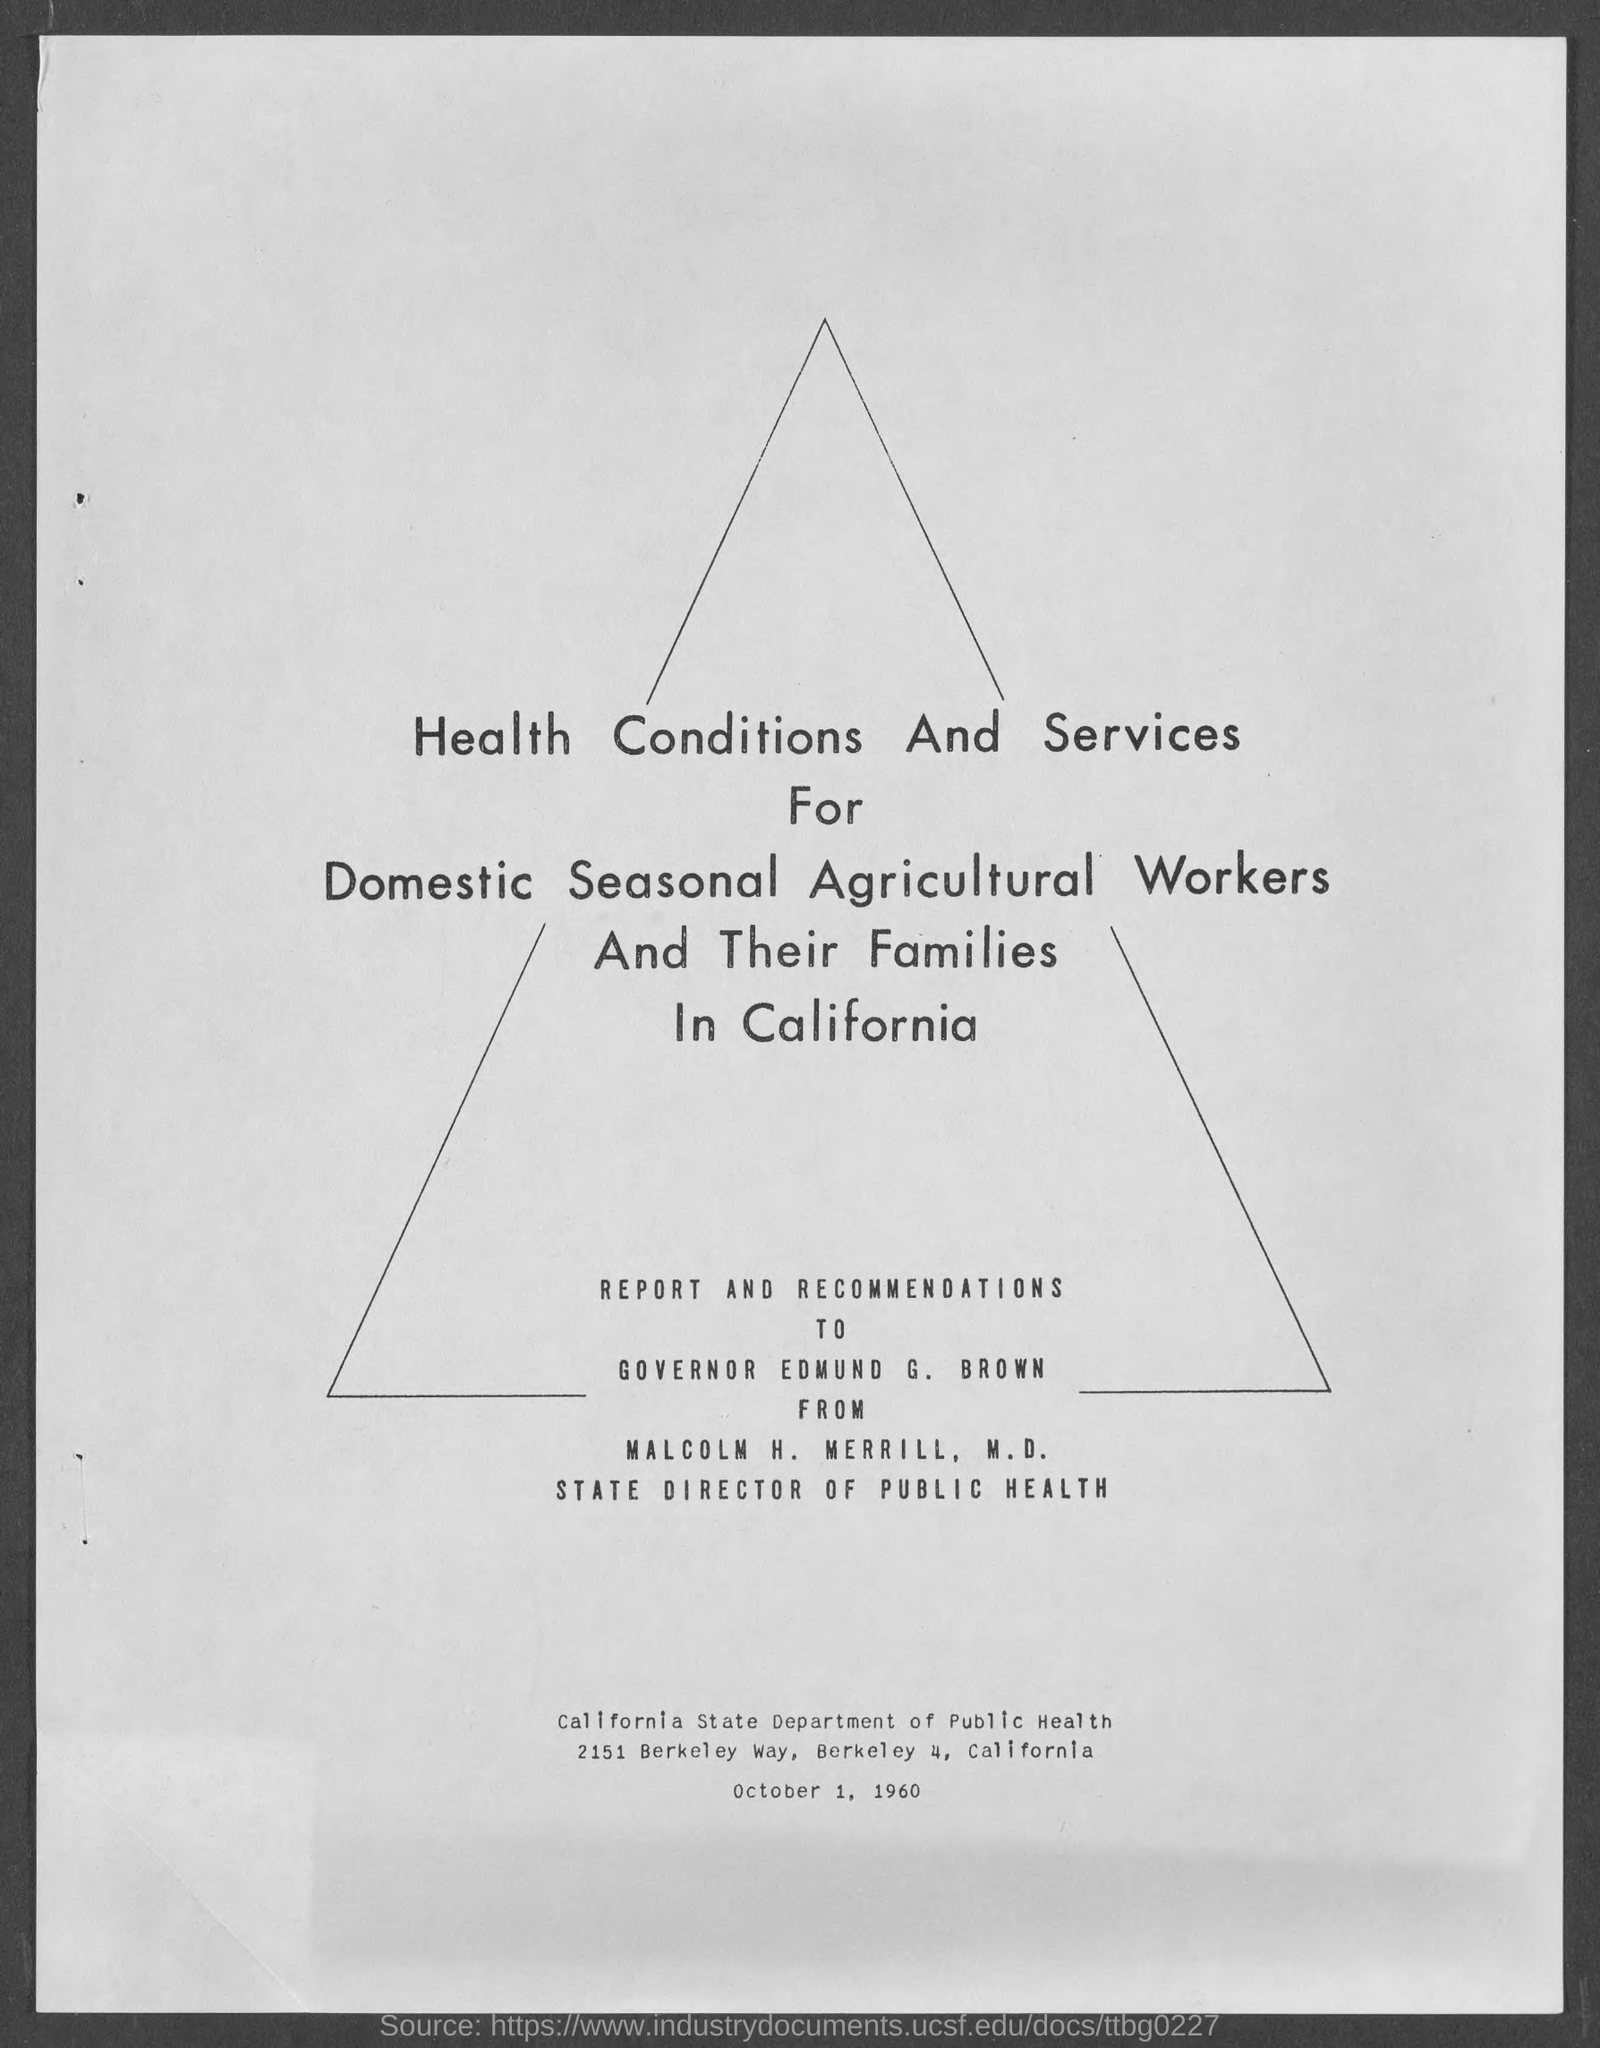Who is the state director of public health ?
Your answer should be compact. Malcolm H. Merrill, M.D. Report and Recommendations are given to ?
Make the answer very short. EDMUND G. BROWN. What is the position of edmund g. brown?
Ensure brevity in your answer.  Governor. 